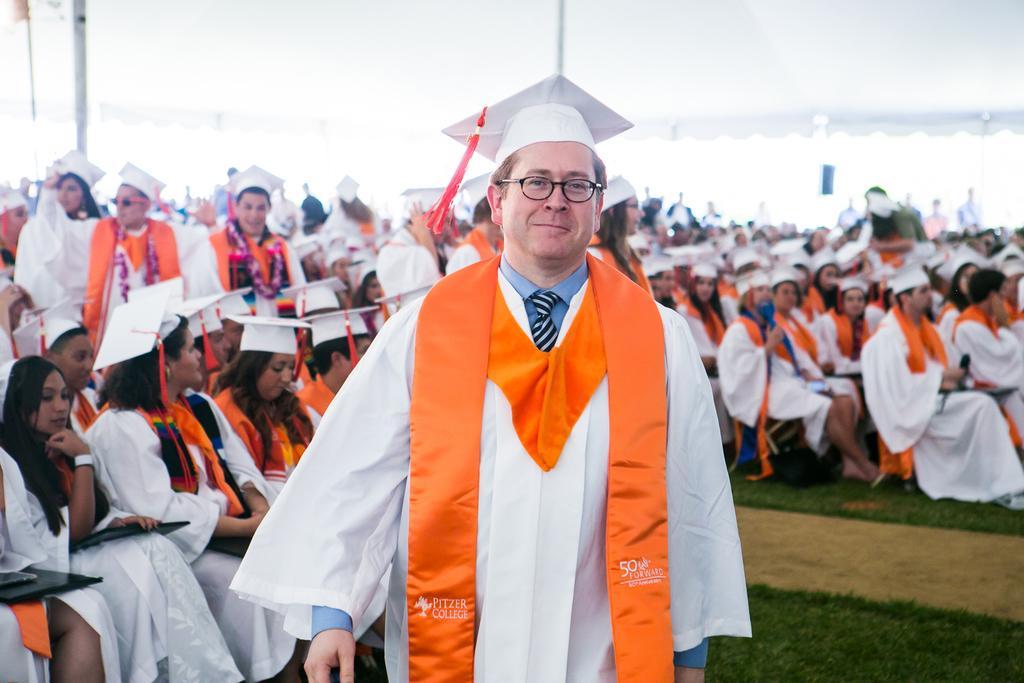Could you give a brief overview of what you see in this image? In this image I see number of people in which most of them are sitting and rest of them are standing and I see that all of them are wearing same dress and white color caps on their heads and I see that this man is smiling and I see the ground on which there is green grass and I see that it is white in the background and I see 2 poles. 